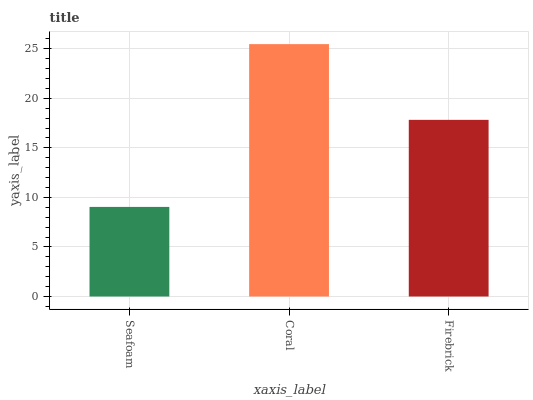Is Seafoam the minimum?
Answer yes or no. Yes. Is Coral the maximum?
Answer yes or no. Yes. Is Firebrick the minimum?
Answer yes or no. No. Is Firebrick the maximum?
Answer yes or no. No. Is Coral greater than Firebrick?
Answer yes or no. Yes. Is Firebrick less than Coral?
Answer yes or no. Yes. Is Firebrick greater than Coral?
Answer yes or no. No. Is Coral less than Firebrick?
Answer yes or no. No. Is Firebrick the high median?
Answer yes or no. Yes. Is Firebrick the low median?
Answer yes or no. Yes. Is Coral the high median?
Answer yes or no. No. Is Coral the low median?
Answer yes or no. No. 